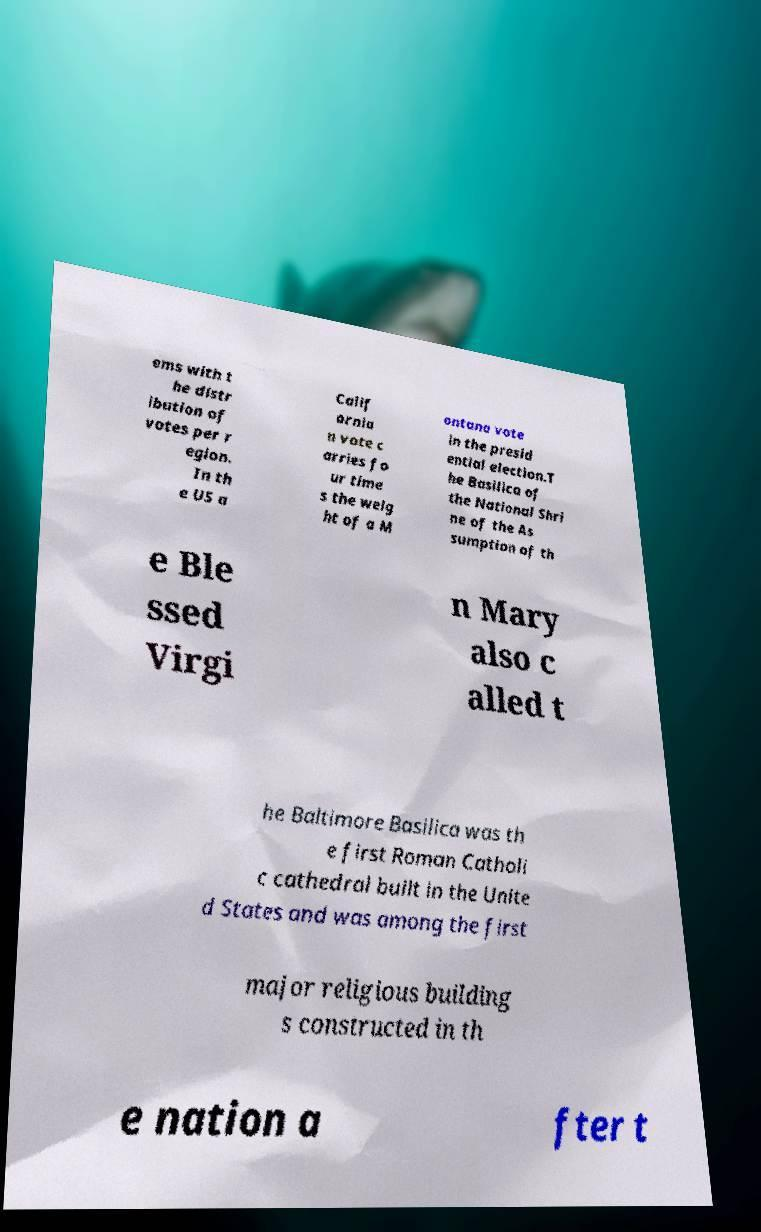Please read and relay the text visible in this image. What does it say? ems with t he distr ibution of votes per r egion. In th e US a Calif ornia n vote c arries fo ur time s the weig ht of a M ontana vote in the presid ential election.T he Basilica of the National Shri ne of the As sumption of th e Ble ssed Virgi n Mary also c alled t he Baltimore Basilica was th e first Roman Catholi c cathedral built in the Unite d States and was among the first major religious building s constructed in th e nation a fter t 